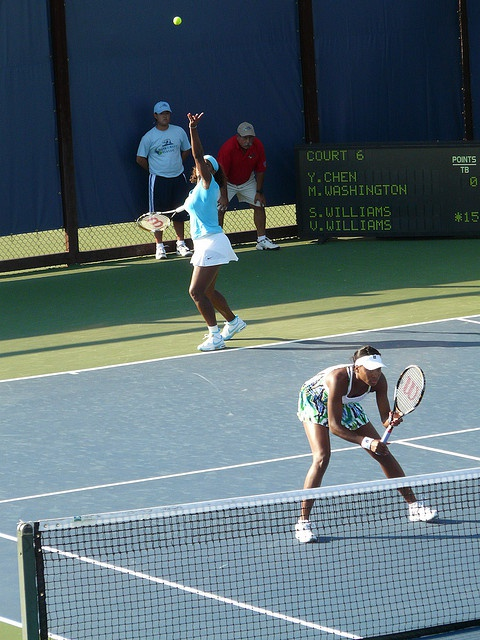Describe the objects in this image and their specific colors. I can see people in navy, black, white, lightblue, and maroon tones, people in navy, white, black, maroon, and darkgray tones, people in navy, black, gray, and darkgray tones, people in navy, black, maroon, and gray tones, and tennis racket in navy, lightgray, darkgray, black, and pink tones in this image. 